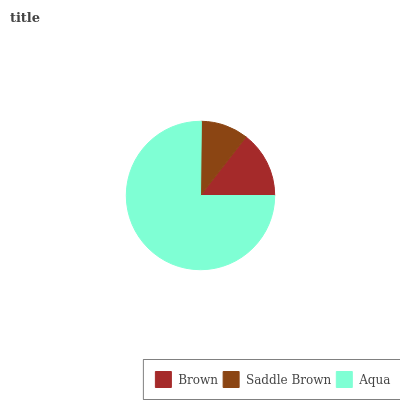Is Saddle Brown the minimum?
Answer yes or no. Yes. Is Aqua the maximum?
Answer yes or no. Yes. Is Aqua the minimum?
Answer yes or no. No. Is Saddle Brown the maximum?
Answer yes or no. No. Is Aqua greater than Saddle Brown?
Answer yes or no. Yes. Is Saddle Brown less than Aqua?
Answer yes or no. Yes. Is Saddle Brown greater than Aqua?
Answer yes or no. No. Is Aqua less than Saddle Brown?
Answer yes or no. No. Is Brown the high median?
Answer yes or no. Yes. Is Brown the low median?
Answer yes or no. Yes. Is Saddle Brown the high median?
Answer yes or no. No. Is Saddle Brown the low median?
Answer yes or no. No. 